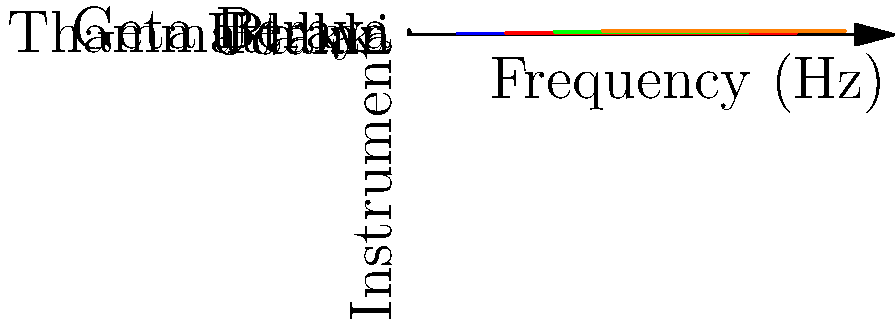Based on the coordinate plane showing the frequency ranges of traditional Sinhalese instruments, which instrument has the widest frequency range? To determine which instrument has the widest frequency range, we need to calculate the range for each instrument and compare them:

1. Geta Beraya: $250 - 50 = 200$ Hz
2. Udakki: $400 - 100 = 300$ Hz
3. Raban: $350 - 150 = 200$ Hz
4. Thammattama: $450 - 200 = 250$ Hz

Comparing these ranges:
- Geta Beraya: 200 Hz
- Udakki: 300 Hz
- Raban: 200 Hz
- Thammattama: 250 Hz

The Udakki has the widest frequency range at 300 Hz.
Answer: Udakki 